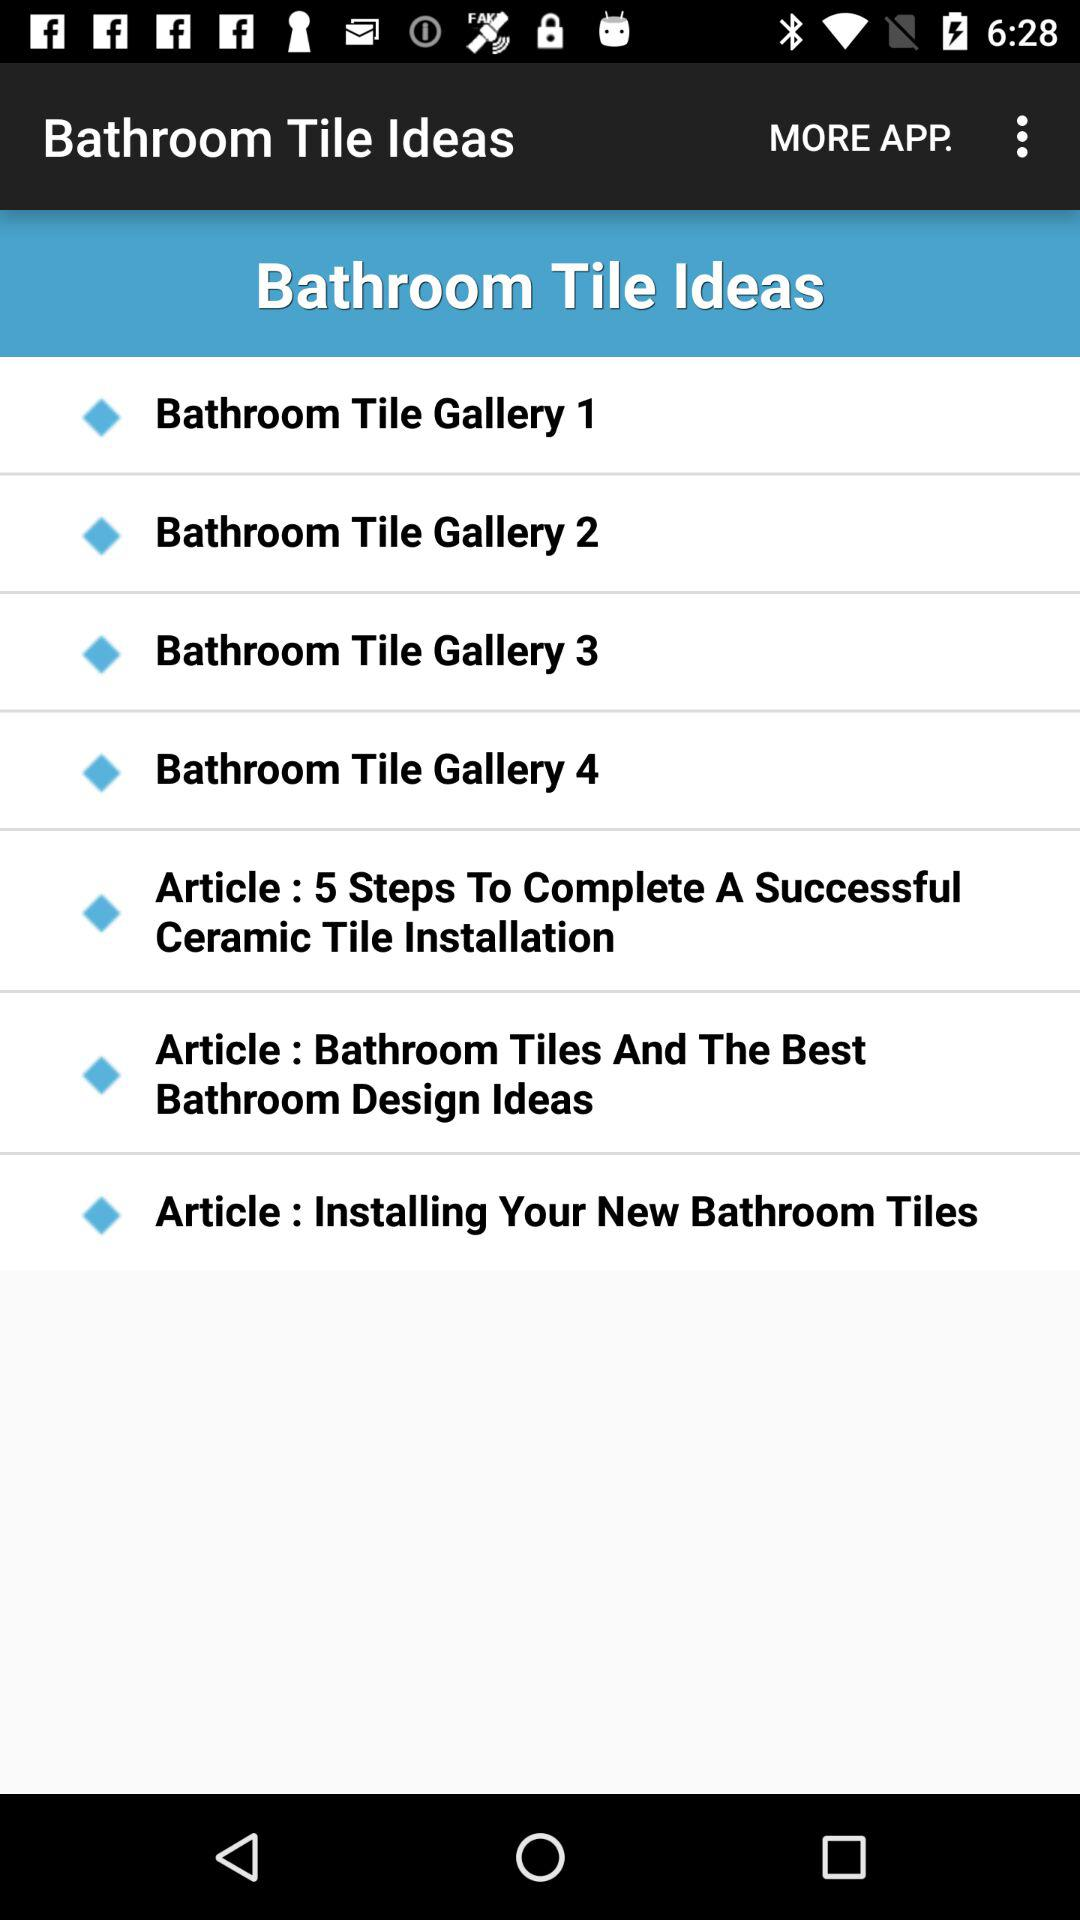What is the name of the application? The name of the application is "Bathroom Tile Ideas". 